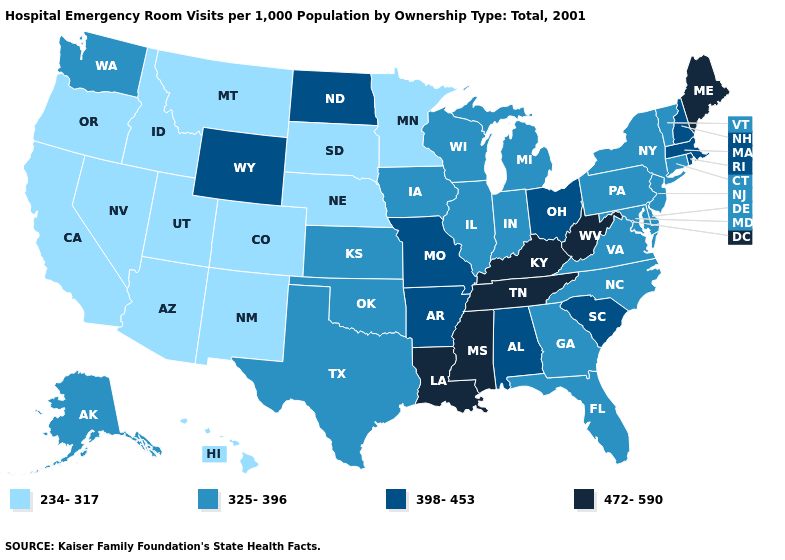Among the states that border North Dakota , which have the highest value?
Write a very short answer. Minnesota, Montana, South Dakota. What is the lowest value in the West?
Keep it brief. 234-317. Does the first symbol in the legend represent the smallest category?
Quick response, please. Yes. What is the highest value in states that border Illinois?
Give a very brief answer. 472-590. Name the states that have a value in the range 325-396?
Short answer required. Alaska, Connecticut, Delaware, Florida, Georgia, Illinois, Indiana, Iowa, Kansas, Maryland, Michigan, New Jersey, New York, North Carolina, Oklahoma, Pennsylvania, Texas, Vermont, Virginia, Washington, Wisconsin. What is the value of New York?
Quick response, please. 325-396. Does the map have missing data?
Be succinct. No. What is the highest value in states that border New Hampshire?
Short answer required. 472-590. How many symbols are there in the legend?
Concise answer only. 4. What is the lowest value in the USA?
Concise answer only. 234-317. What is the value of Maine?
Short answer required. 472-590. What is the value of New Jersey?
Concise answer only. 325-396. Is the legend a continuous bar?
Short answer required. No. Does Florida have a lower value than California?
Quick response, please. No. Does Missouri have the lowest value in the USA?
Give a very brief answer. No. 